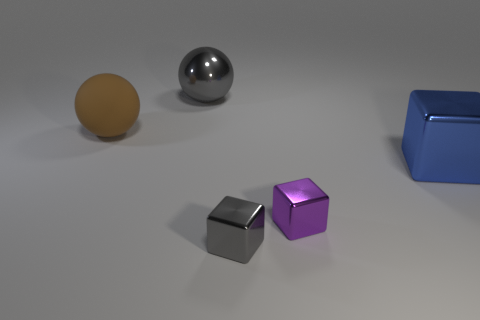There is a brown matte sphere; what number of gray metal balls are right of it?
Your answer should be very brief. 1. Is the number of purple cubes greater than the number of large cyan metal blocks?
Provide a short and direct response. Yes. The big thing that is both left of the purple object and in front of the shiny ball has what shape?
Your response must be concise. Sphere. Are there any yellow metallic spheres?
Your answer should be very brief. No. There is a big gray thing that is the same shape as the brown thing; what is its material?
Keep it short and to the point. Metal. What shape is the shiny thing that is on the left side of the tiny object in front of the tiny metal object behind the tiny gray cube?
Provide a succinct answer. Sphere. There is a block that is the same color as the large shiny sphere; what material is it?
Keep it short and to the point. Metal. What number of other objects have the same shape as the matte object?
Make the answer very short. 1. Do the large rubber sphere behind the gray metallic block and the small block that is behind the tiny gray thing have the same color?
Offer a terse response. No. What material is the other block that is the same size as the purple metal block?
Provide a succinct answer. Metal. 